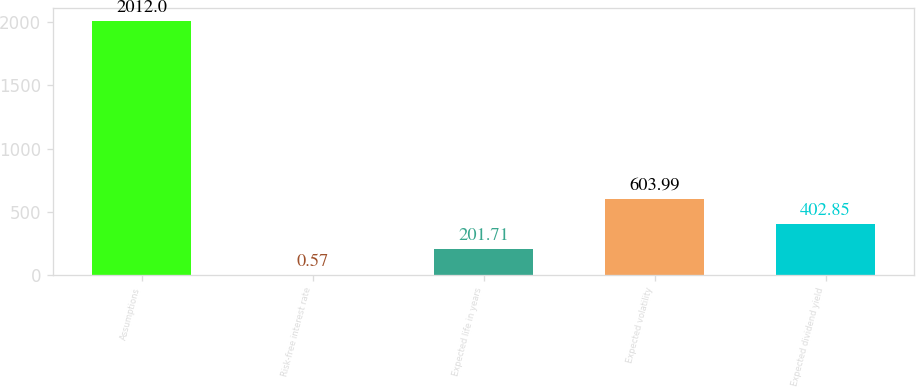Convert chart. <chart><loc_0><loc_0><loc_500><loc_500><bar_chart><fcel>Assumptions<fcel>Risk-free interest rate<fcel>Expected life in years<fcel>Expected volatility<fcel>Expected dividend yield<nl><fcel>2012<fcel>0.57<fcel>201.71<fcel>603.99<fcel>402.85<nl></chart> 